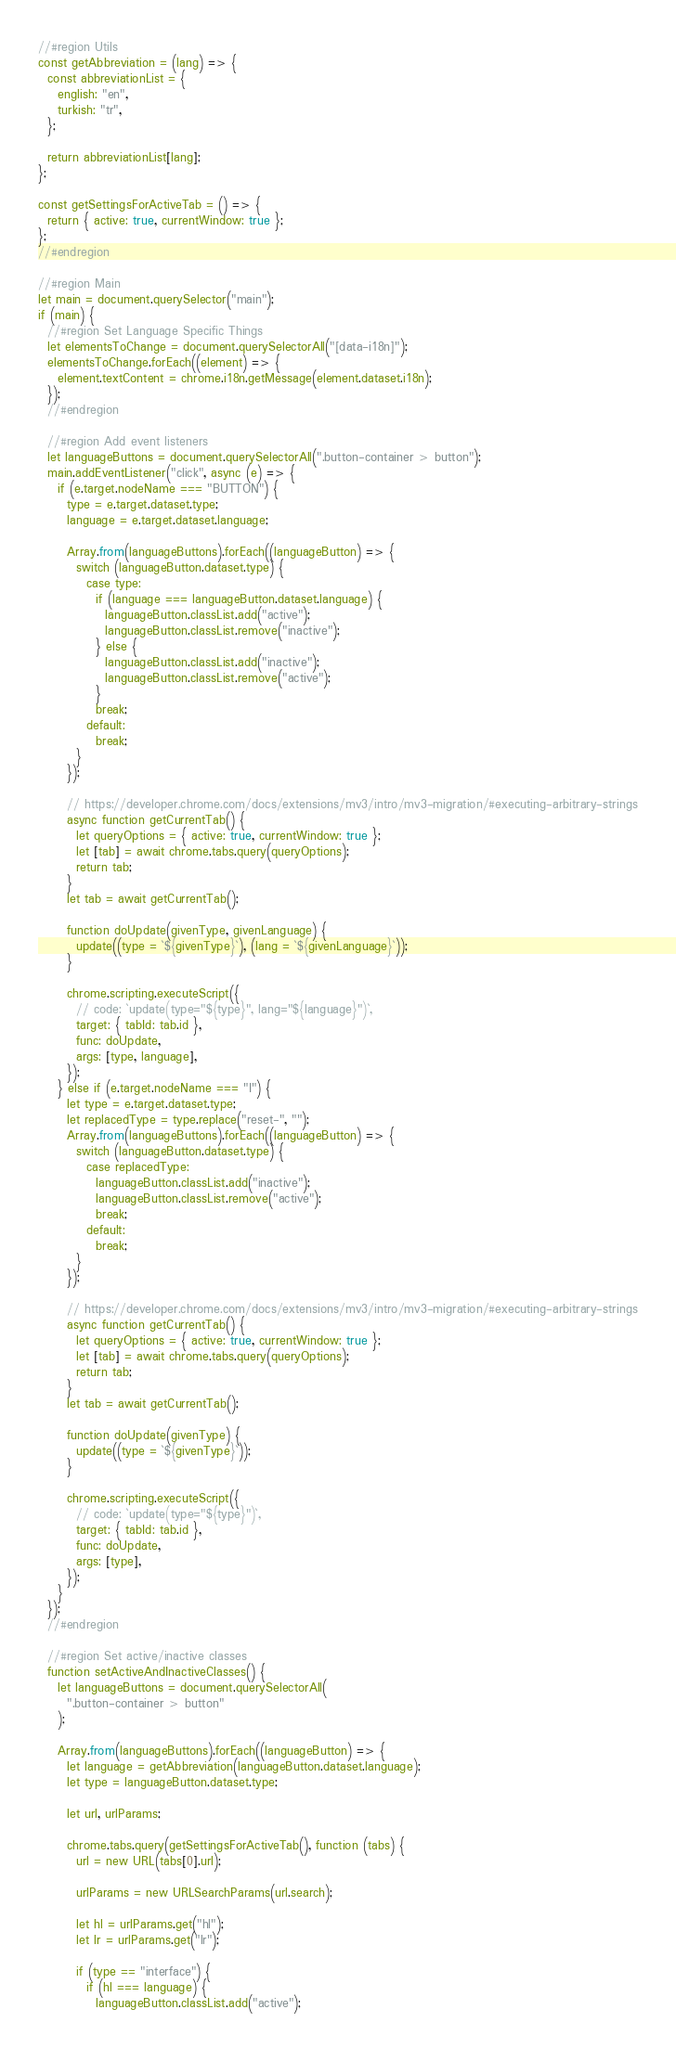Convert code to text. <code><loc_0><loc_0><loc_500><loc_500><_JavaScript_>//#region Utils
const getAbbreviation = (lang) => {
  const abbreviationList = {
    english: "en",
    turkish: "tr",
  };

  return abbreviationList[lang];
};

const getSettingsForActiveTab = () => {
  return { active: true, currentWindow: true };
};
//#endregion

//#region Main
let main = document.querySelector("main");
if (main) {
  //#region Set Language Specific Things
  let elementsToChange = document.querySelectorAll("[data-i18n]");
  elementsToChange.forEach((element) => {
    element.textContent = chrome.i18n.getMessage(element.dataset.i18n);
  });
  //#endregion

  //#region Add event listeners
  let languageButtons = document.querySelectorAll(".button-container > button");
  main.addEventListener("click", async (e) => {
    if (e.target.nodeName === "BUTTON") {
      type = e.target.dataset.type;
      language = e.target.dataset.language;

      Array.from(languageButtons).forEach((languageButton) => {
        switch (languageButton.dataset.type) {
          case type:
            if (language === languageButton.dataset.language) {
              languageButton.classList.add("active");
              languageButton.classList.remove("inactive");
            } else {
              languageButton.classList.add("inactive");
              languageButton.classList.remove("active");
            }
            break;
          default:
            break;
        }
      });

      // https://developer.chrome.com/docs/extensions/mv3/intro/mv3-migration/#executing-arbitrary-strings
      async function getCurrentTab() {
        let queryOptions = { active: true, currentWindow: true };
        let [tab] = await chrome.tabs.query(queryOptions);
        return tab;
      }
      let tab = await getCurrentTab();

      function doUpdate(givenType, givenLanguage) {
        update((type = `${givenType}`), (lang = `${givenLanguage}`));
      }

      chrome.scripting.executeScript({
        // code: `update(type="${type}", lang="${language}")`,
        target: { tabId: tab.id },
        func: doUpdate,
        args: [type, language],
      });
    } else if (e.target.nodeName === "I") {
      let type = e.target.dataset.type;
      let replacedType = type.replace("reset-", "");
      Array.from(languageButtons).forEach((languageButton) => {
        switch (languageButton.dataset.type) {
          case replacedType:
            languageButton.classList.add("inactive");
            languageButton.classList.remove("active");
            break;
          default:
            break;
        }
      });

      // https://developer.chrome.com/docs/extensions/mv3/intro/mv3-migration/#executing-arbitrary-strings
      async function getCurrentTab() {
        let queryOptions = { active: true, currentWindow: true };
        let [tab] = await chrome.tabs.query(queryOptions);
        return tab;
      }
      let tab = await getCurrentTab();

      function doUpdate(givenType) {
        update((type = `${givenType}`));
      }

      chrome.scripting.executeScript({
        // code: `update(type="${type}")`,
        target: { tabId: tab.id },
        func: doUpdate,
        args: [type],
      });
    }
  });
  //#endregion

  //#region Set active/inactive classes
  function setActiveAndInactiveClasses() {
    let languageButtons = document.querySelectorAll(
      ".button-container > button"
    );

    Array.from(languageButtons).forEach((languageButton) => {
      let language = getAbbreviation(languageButton.dataset.language);
      let type = languageButton.dataset.type;

      let url, urlParams;

      chrome.tabs.query(getSettingsForActiveTab(), function (tabs) {
        url = new URL(tabs[0].url);

        urlParams = new URLSearchParams(url.search);

        let hl = urlParams.get("hl");
        let lr = urlParams.get("lr");

        if (type == "interface") {
          if (hl === language) {
            languageButton.classList.add("active");</code> 